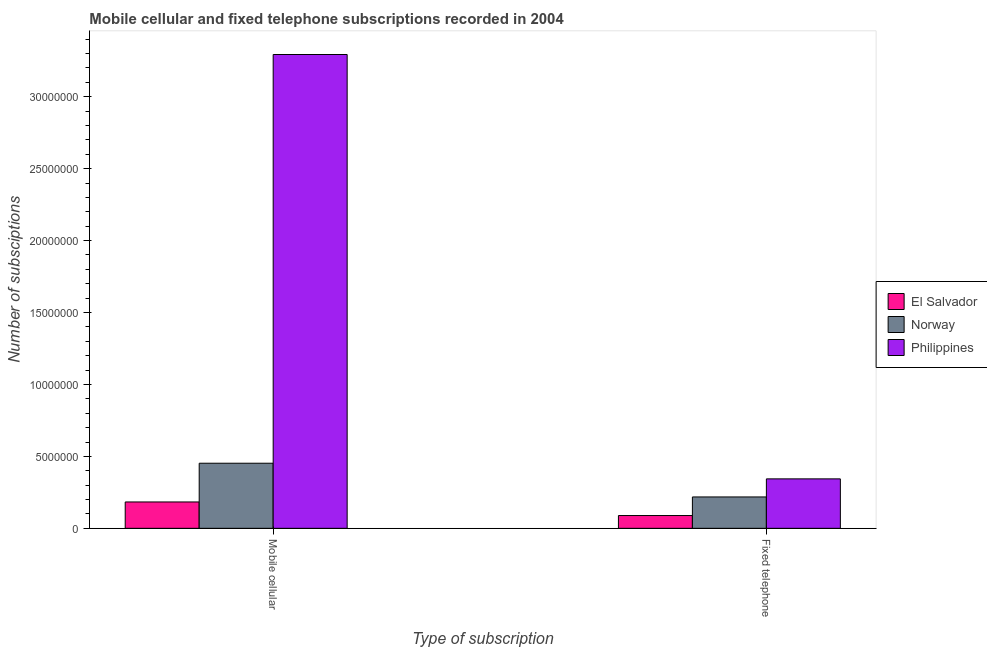How many different coloured bars are there?
Offer a very short reply. 3. Are the number of bars per tick equal to the number of legend labels?
Give a very brief answer. Yes. Are the number of bars on each tick of the X-axis equal?
Offer a terse response. Yes. What is the label of the 2nd group of bars from the left?
Your answer should be compact. Fixed telephone. What is the number of fixed telephone subscriptions in Norway?
Provide a succinct answer. 2.18e+06. Across all countries, what is the maximum number of fixed telephone subscriptions?
Keep it short and to the point. 3.44e+06. Across all countries, what is the minimum number of fixed telephone subscriptions?
Offer a very short reply. 8.88e+05. In which country was the number of mobile cellular subscriptions maximum?
Keep it short and to the point. Philippines. In which country was the number of mobile cellular subscriptions minimum?
Your answer should be compact. El Salvador. What is the total number of fixed telephone subscriptions in the graph?
Ensure brevity in your answer.  6.51e+06. What is the difference between the number of mobile cellular subscriptions in Norway and that in El Salvador?
Give a very brief answer. 2.69e+06. What is the difference between the number of mobile cellular subscriptions in El Salvador and the number of fixed telephone subscriptions in Norway?
Offer a very short reply. -3.48e+05. What is the average number of fixed telephone subscriptions per country?
Offer a very short reply. 2.17e+06. What is the difference between the number of mobile cellular subscriptions and number of fixed telephone subscriptions in Philippines?
Give a very brief answer. 2.95e+07. In how many countries, is the number of mobile cellular subscriptions greater than 8000000 ?
Offer a very short reply. 1. What is the ratio of the number of mobile cellular subscriptions in Norway to that in Philippines?
Your response must be concise. 0.14. Is the number of fixed telephone subscriptions in El Salvador less than that in Norway?
Ensure brevity in your answer.  Yes. What does the 3rd bar from the left in Mobile cellular represents?
Your answer should be very brief. Philippines. What does the 3rd bar from the right in Fixed telephone represents?
Give a very brief answer. El Salvador. How many countries are there in the graph?
Your answer should be compact. 3. Are the values on the major ticks of Y-axis written in scientific E-notation?
Give a very brief answer. No. How many legend labels are there?
Make the answer very short. 3. What is the title of the graph?
Make the answer very short. Mobile cellular and fixed telephone subscriptions recorded in 2004. Does "Mauritius" appear as one of the legend labels in the graph?
Your answer should be compact. No. What is the label or title of the X-axis?
Make the answer very short. Type of subscription. What is the label or title of the Y-axis?
Keep it short and to the point. Number of subsciptions. What is the Number of subsciptions of El Salvador in Mobile cellular?
Keep it short and to the point. 1.83e+06. What is the Number of subsciptions in Norway in Mobile cellular?
Your response must be concise. 4.52e+06. What is the Number of subsciptions in Philippines in Mobile cellular?
Give a very brief answer. 3.29e+07. What is the Number of subsciptions of El Salvador in Fixed telephone?
Provide a succinct answer. 8.88e+05. What is the Number of subsciptions of Norway in Fixed telephone?
Your answer should be very brief. 2.18e+06. What is the Number of subsciptions of Philippines in Fixed telephone?
Offer a very short reply. 3.44e+06. Across all Type of subscription, what is the maximum Number of subsciptions of El Salvador?
Keep it short and to the point. 1.83e+06. Across all Type of subscription, what is the maximum Number of subsciptions of Norway?
Offer a terse response. 4.52e+06. Across all Type of subscription, what is the maximum Number of subsciptions of Philippines?
Keep it short and to the point. 3.29e+07. Across all Type of subscription, what is the minimum Number of subsciptions of El Salvador?
Provide a short and direct response. 8.88e+05. Across all Type of subscription, what is the minimum Number of subsciptions of Norway?
Your response must be concise. 2.18e+06. Across all Type of subscription, what is the minimum Number of subsciptions in Philippines?
Your answer should be compact. 3.44e+06. What is the total Number of subsciptions of El Salvador in the graph?
Provide a succinct answer. 2.72e+06. What is the total Number of subsciptions in Norway in the graph?
Offer a terse response. 6.71e+06. What is the total Number of subsciptions in Philippines in the graph?
Offer a very short reply. 3.64e+07. What is the difference between the Number of subsciptions in El Salvador in Mobile cellular and that in Fixed telephone?
Keep it short and to the point. 9.45e+05. What is the difference between the Number of subsciptions of Norway in Mobile cellular and that in Fixed telephone?
Give a very brief answer. 2.34e+06. What is the difference between the Number of subsciptions of Philippines in Mobile cellular and that in Fixed telephone?
Provide a succinct answer. 2.95e+07. What is the difference between the Number of subsciptions of El Salvador in Mobile cellular and the Number of subsciptions of Norway in Fixed telephone?
Provide a succinct answer. -3.48e+05. What is the difference between the Number of subsciptions of El Salvador in Mobile cellular and the Number of subsciptions of Philippines in Fixed telephone?
Ensure brevity in your answer.  -1.60e+06. What is the difference between the Number of subsciptions of Norway in Mobile cellular and the Number of subsciptions of Philippines in Fixed telephone?
Make the answer very short. 1.09e+06. What is the average Number of subsciptions of El Salvador per Type of subscription?
Make the answer very short. 1.36e+06. What is the average Number of subsciptions in Norway per Type of subscription?
Offer a terse response. 3.35e+06. What is the average Number of subsciptions in Philippines per Type of subscription?
Offer a very short reply. 1.82e+07. What is the difference between the Number of subsciptions of El Salvador and Number of subsciptions of Norway in Mobile cellular?
Offer a very short reply. -2.69e+06. What is the difference between the Number of subsciptions in El Salvador and Number of subsciptions in Philippines in Mobile cellular?
Your answer should be very brief. -3.11e+07. What is the difference between the Number of subsciptions in Norway and Number of subsciptions in Philippines in Mobile cellular?
Offer a very short reply. -2.84e+07. What is the difference between the Number of subsciptions in El Salvador and Number of subsciptions in Norway in Fixed telephone?
Your answer should be compact. -1.29e+06. What is the difference between the Number of subsciptions in El Salvador and Number of subsciptions in Philippines in Fixed telephone?
Provide a short and direct response. -2.55e+06. What is the difference between the Number of subsciptions in Norway and Number of subsciptions in Philippines in Fixed telephone?
Provide a short and direct response. -1.26e+06. What is the ratio of the Number of subsciptions in El Salvador in Mobile cellular to that in Fixed telephone?
Make the answer very short. 2.06. What is the ratio of the Number of subsciptions of Norway in Mobile cellular to that in Fixed telephone?
Your answer should be very brief. 2.08. What is the ratio of the Number of subsciptions in Philippines in Mobile cellular to that in Fixed telephone?
Provide a succinct answer. 9.58. What is the difference between the highest and the second highest Number of subsciptions of El Salvador?
Make the answer very short. 9.45e+05. What is the difference between the highest and the second highest Number of subsciptions of Norway?
Ensure brevity in your answer.  2.34e+06. What is the difference between the highest and the second highest Number of subsciptions in Philippines?
Provide a succinct answer. 2.95e+07. What is the difference between the highest and the lowest Number of subsciptions in El Salvador?
Give a very brief answer. 9.45e+05. What is the difference between the highest and the lowest Number of subsciptions in Norway?
Your response must be concise. 2.34e+06. What is the difference between the highest and the lowest Number of subsciptions in Philippines?
Offer a very short reply. 2.95e+07. 